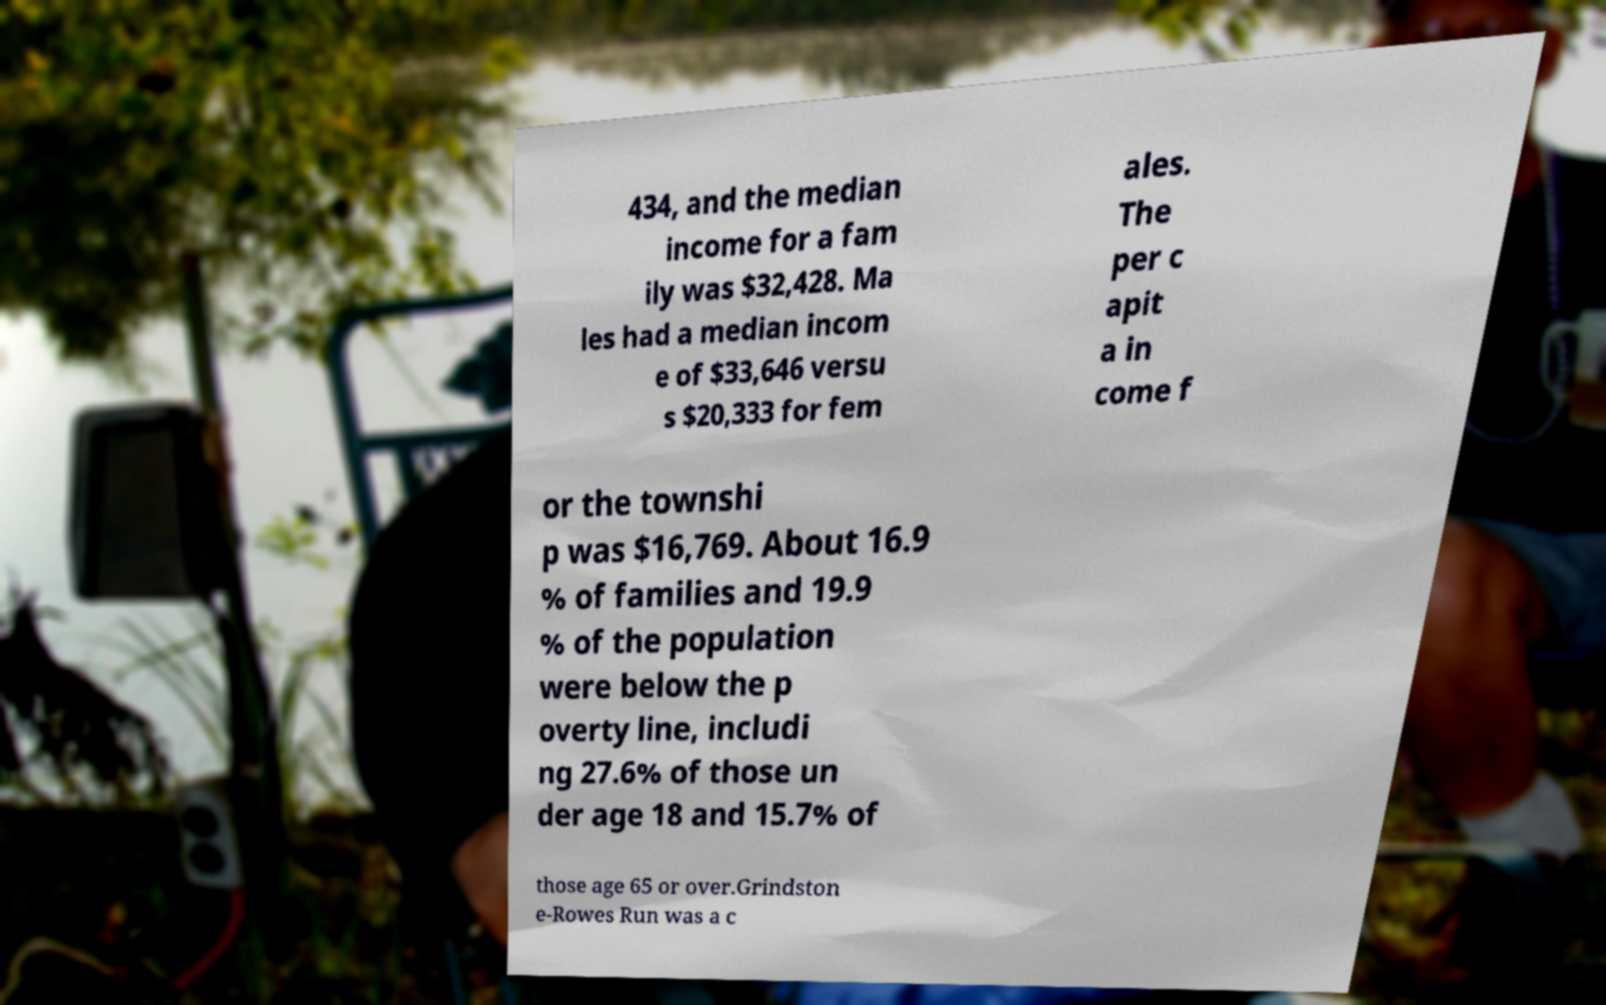For documentation purposes, I need the text within this image transcribed. Could you provide that? 434, and the median income for a fam ily was $32,428. Ma les had a median incom e of $33,646 versu s $20,333 for fem ales. The per c apit a in come f or the townshi p was $16,769. About 16.9 % of families and 19.9 % of the population were below the p overty line, includi ng 27.6% of those un der age 18 and 15.7% of those age 65 or over.Grindston e-Rowes Run was a c 